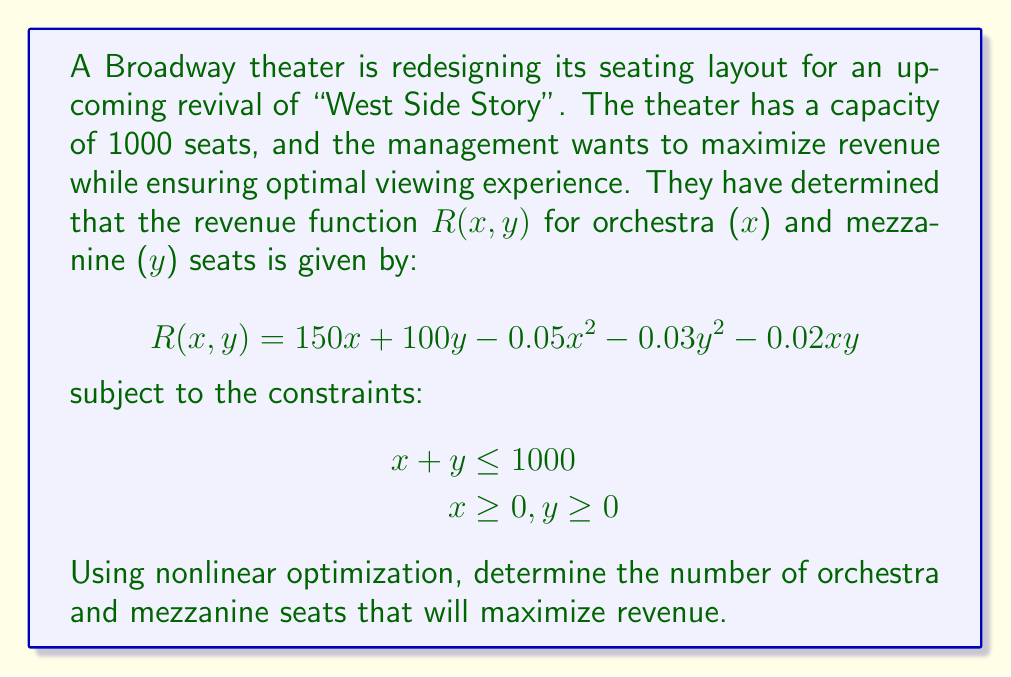Can you answer this question? To solve this nonlinear optimization problem, we'll use the method of Lagrange multipliers:

1) First, we form the Lagrangian function:
   $$L(x, y, \lambda) = 150x + 100y - 0.05x^2 - 0.03y^2 - 0.02xy - \lambda(x + y - 1000)$$

2) We then take partial derivatives and set them equal to zero:
   $$\frac{\partial L}{\partial x} = 150 - 0.1x - 0.02y - \lambda = 0$$
   $$\frac{\partial L}{\partial y} = 100 - 0.06y - 0.02x - \lambda = 0$$
   $$\frac{\partial L}{\partial \lambda} = 1000 - x - y = 0$$

3) From the first two equations:
   $$150 - 0.1x - 0.02y = 100 - 0.06y - 0.02x$$
   $$50 = 0.08x - 0.04y$$
   $$x = 625 + 0.5y$$

4) Substituting this into the third equation:
   $$1000 = (625 + 0.5y) + y$$
   $$375 = 1.5y$$
   $$y = 250$$

5) Then, substituting back:
   $$x = 625 + 0.5(250) = 750$$

6) We can verify that this is indeed a maximum by checking the second derivatives:
   $$\frac{\partial^2 L}{\partial x^2} = -0.1 < 0$$
   $$\frac{\partial^2 L}{\partial y^2} = -0.06 < 0$$

   The negative second derivatives confirm this is a maximum.
Answer: 750 orchestra seats, 250 mezzanine seats 